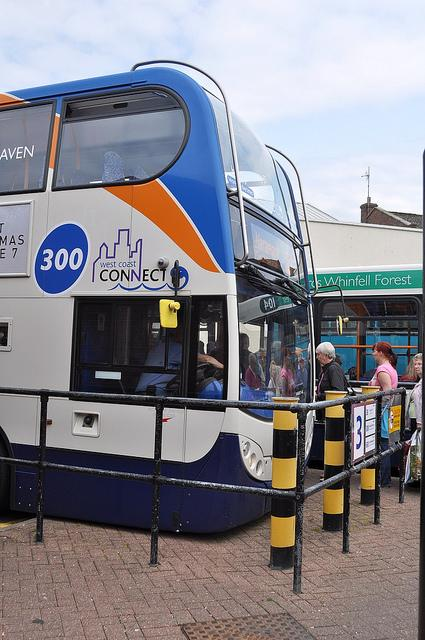The bus in the background is going to the home of which endangered animal?

Choices:
A) bald eagle
B) red squirrel
C) peregrine falcon
D) koala red squirrel 